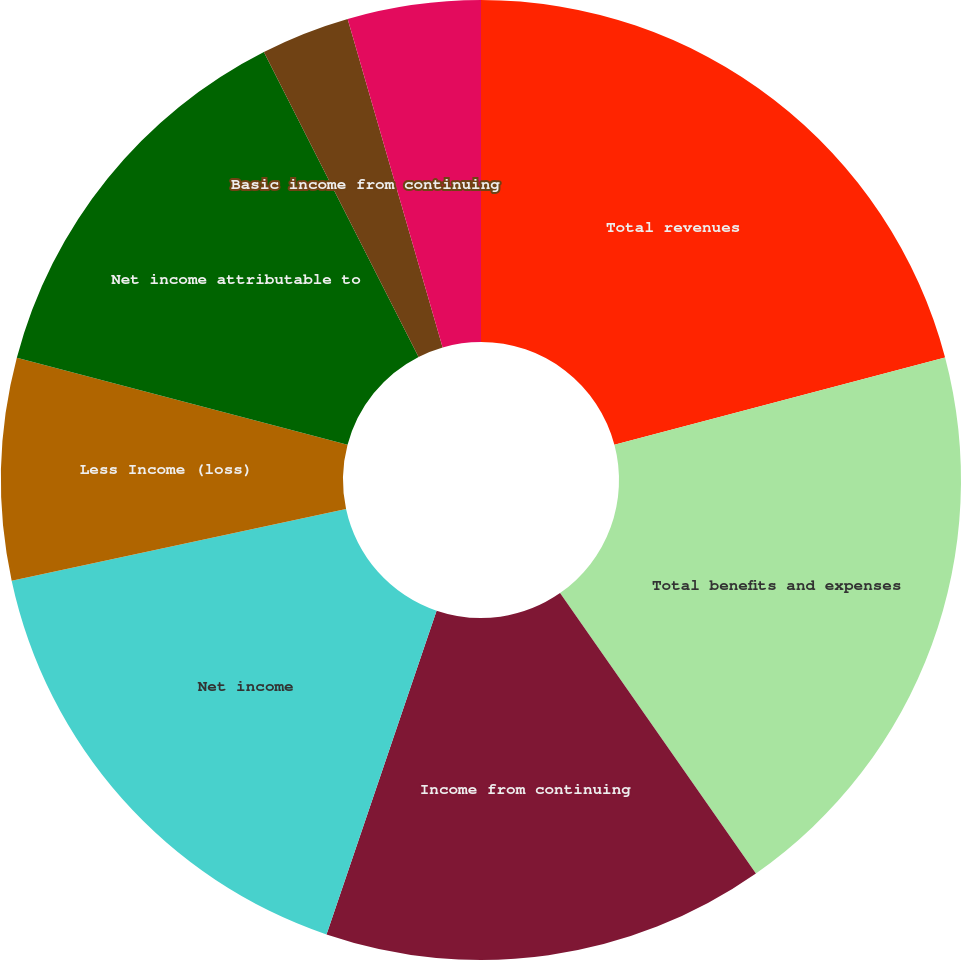Convert chart. <chart><loc_0><loc_0><loc_500><loc_500><pie_chart><fcel>Total revenues<fcel>Total benefits and expenses<fcel>Income from continuing<fcel>Net income<fcel>Less Income (loss)<fcel>Net income attributable to<fcel>Basic income from continuing<fcel>Diluted income from continuing<fcel>Basic net income attributable<nl><fcel>20.89%<fcel>19.4%<fcel>14.92%<fcel>16.42%<fcel>7.46%<fcel>13.43%<fcel>2.99%<fcel>0.0%<fcel>4.48%<nl></chart> 